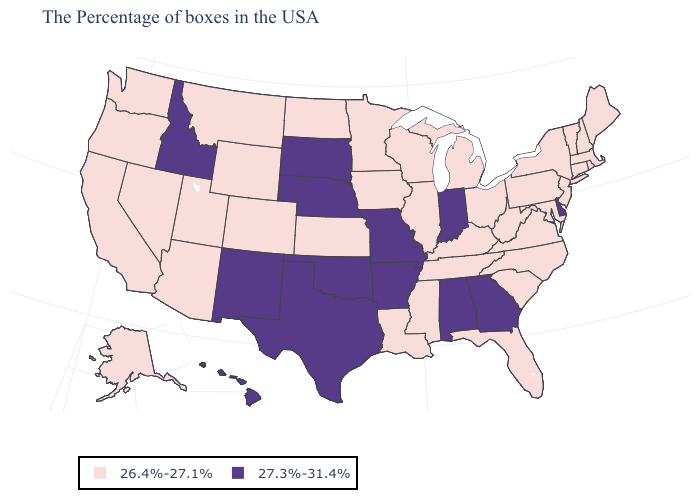Does Alabama have the highest value in the USA?
Write a very short answer. Yes. Name the states that have a value in the range 27.3%-31.4%?
Quick response, please. Delaware, Georgia, Indiana, Alabama, Missouri, Arkansas, Nebraska, Oklahoma, Texas, South Dakota, New Mexico, Idaho, Hawaii. Which states hav the highest value in the West?
Answer briefly. New Mexico, Idaho, Hawaii. What is the highest value in the MidWest ?
Quick response, please. 27.3%-31.4%. Does Mississippi have the same value as Georgia?
Keep it brief. No. Name the states that have a value in the range 26.4%-27.1%?
Concise answer only. Maine, Massachusetts, Rhode Island, New Hampshire, Vermont, Connecticut, New York, New Jersey, Maryland, Pennsylvania, Virginia, North Carolina, South Carolina, West Virginia, Ohio, Florida, Michigan, Kentucky, Tennessee, Wisconsin, Illinois, Mississippi, Louisiana, Minnesota, Iowa, Kansas, North Dakota, Wyoming, Colorado, Utah, Montana, Arizona, Nevada, California, Washington, Oregon, Alaska. Does the first symbol in the legend represent the smallest category?
Be succinct. Yes. Is the legend a continuous bar?
Keep it brief. No. Among the states that border New York , which have the highest value?
Keep it brief. Massachusetts, Vermont, Connecticut, New Jersey, Pennsylvania. What is the value of Louisiana?
Short answer required. 26.4%-27.1%. Does North Carolina have the lowest value in the South?
Be succinct. Yes. What is the value of Connecticut?
Write a very short answer. 26.4%-27.1%. Does the first symbol in the legend represent the smallest category?
Concise answer only. Yes. What is the value of Tennessee?
Keep it brief. 26.4%-27.1%. What is the value of Louisiana?
Quick response, please. 26.4%-27.1%. 